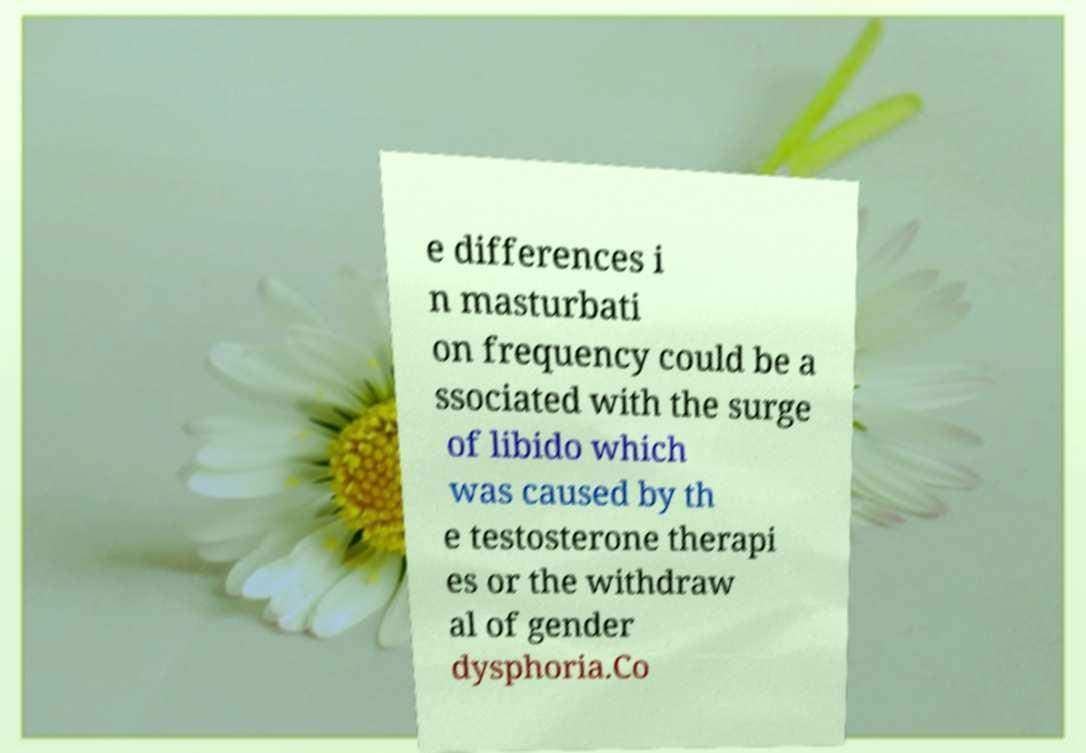Can you accurately transcribe the text from the provided image for me? e differences i n masturbati on frequency could be a ssociated with the surge of libido which was caused by th e testosterone therapi es or the withdraw al of gender dysphoria.Co 